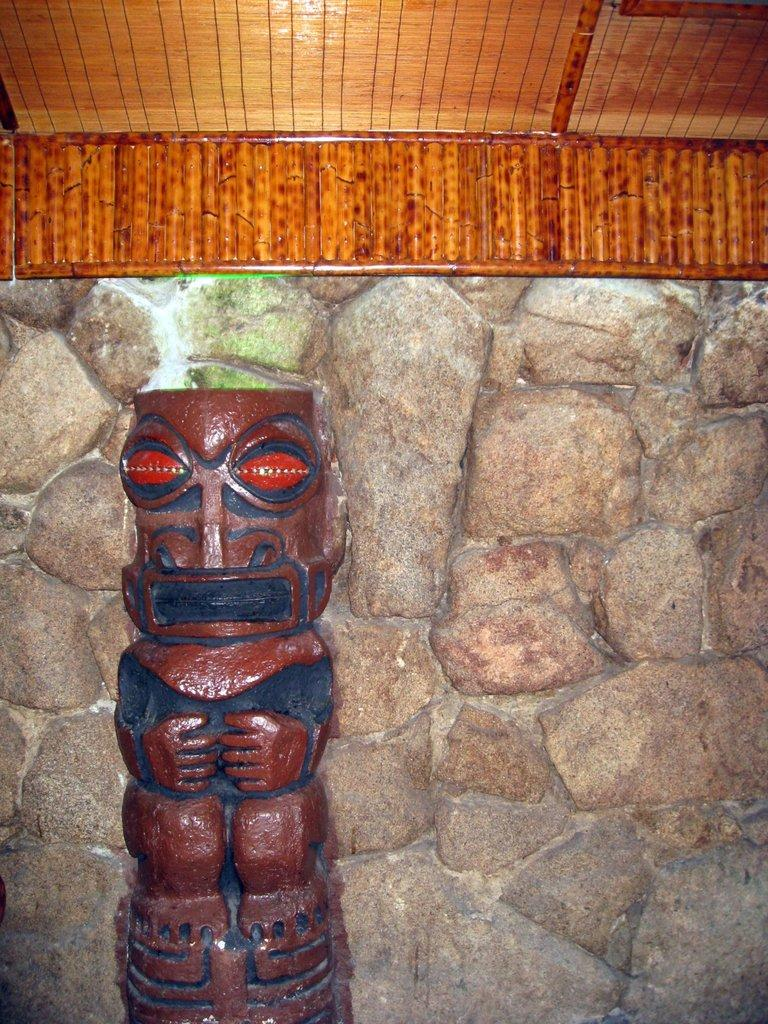What is the main subject of the image? There is a stone sculpture in the image. Can you describe the appearance of the stone sculpture? The stone sculpture has a brown paint on it. What is located behind the stone sculpture? There are stones behind the sculpture. What type of roof is present above the sculpture? There is a wooden roof above the sculpture. What type of dinner is being served under the wooden roof in the image? There is no dinner or any indication of food in the image; it features a stone sculpture with a wooden roof above it. 